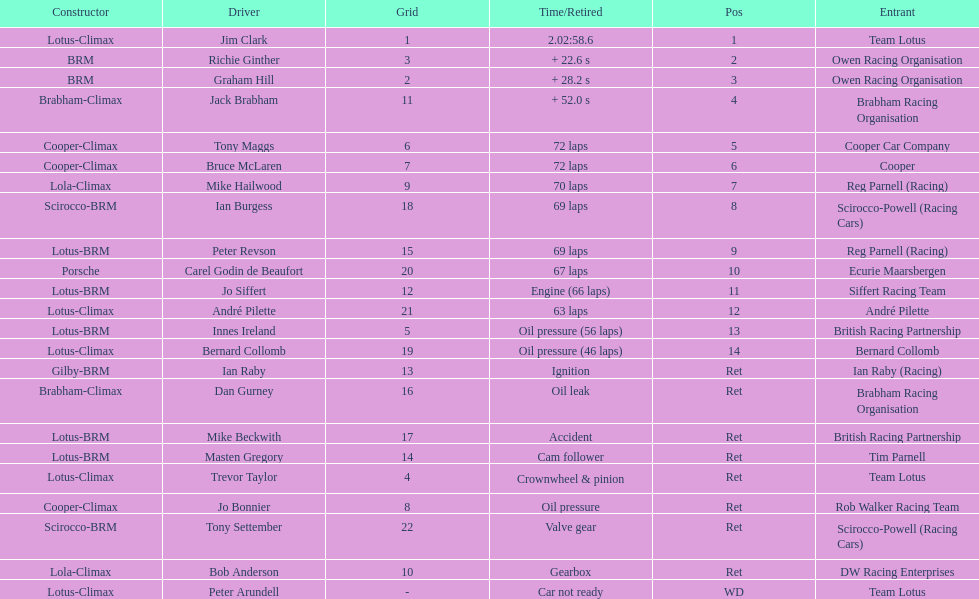How many different drivers are listed? 23. 